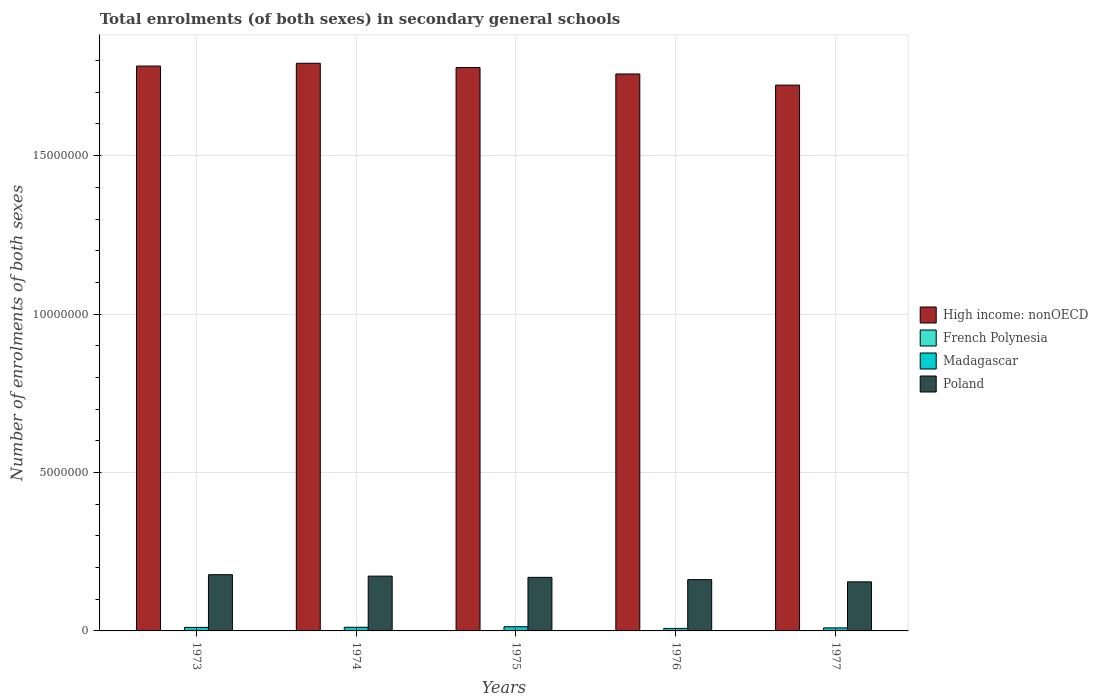How many different coloured bars are there?
Your answer should be very brief. 4. How many bars are there on the 3rd tick from the left?
Keep it short and to the point. 4. How many bars are there on the 5th tick from the right?
Offer a terse response. 4. What is the label of the 3rd group of bars from the left?
Offer a terse response. 1975. What is the number of enrolments in secondary schools in French Polynesia in 1974?
Your response must be concise. 6597. Across all years, what is the maximum number of enrolments in secondary schools in High income: nonOECD?
Give a very brief answer. 1.79e+07. Across all years, what is the minimum number of enrolments in secondary schools in French Polynesia?
Keep it short and to the point. 6239. In which year was the number of enrolments in secondary schools in French Polynesia maximum?
Offer a terse response. 1977. In which year was the number of enrolments in secondary schools in French Polynesia minimum?
Provide a succinct answer. 1973. What is the total number of enrolments in secondary schools in Poland in the graph?
Provide a succinct answer. 8.36e+06. What is the difference between the number of enrolments in secondary schools in Poland in 1974 and that in 1977?
Offer a terse response. 1.81e+05. What is the difference between the number of enrolments in secondary schools in High income: nonOECD in 1973 and the number of enrolments in secondary schools in French Polynesia in 1974?
Keep it short and to the point. 1.78e+07. What is the average number of enrolments in secondary schools in Poland per year?
Make the answer very short. 1.67e+06. In the year 1976, what is the difference between the number of enrolments in secondary schools in Poland and number of enrolments in secondary schools in Madagascar?
Your answer should be very brief. 1.54e+06. What is the ratio of the number of enrolments in secondary schools in French Polynesia in 1976 to that in 1977?
Your answer should be very brief. 0.94. Is the difference between the number of enrolments in secondary schools in Poland in 1974 and 1975 greater than the difference between the number of enrolments in secondary schools in Madagascar in 1974 and 1975?
Provide a succinct answer. Yes. What is the difference between the highest and the second highest number of enrolments in secondary schools in Madagascar?
Your answer should be very brief. 1.74e+04. What is the difference between the highest and the lowest number of enrolments in secondary schools in Madagascar?
Keep it short and to the point. 5.29e+04. In how many years, is the number of enrolments in secondary schools in High income: nonOECD greater than the average number of enrolments in secondary schools in High income: nonOECD taken over all years?
Your answer should be very brief. 3. What does the 4th bar from the left in 1975 represents?
Provide a succinct answer. Poland. What does the 3rd bar from the right in 1976 represents?
Provide a short and direct response. French Polynesia. Is it the case that in every year, the sum of the number of enrolments in secondary schools in Madagascar and number of enrolments in secondary schools in Poland is greater than the number of enrolments in secondary schools in High income: nonOECD?
Make the answer very short. No. Are all the bars in the graph horizontal?
Keep it short and to the point. No. How many years are there in the graph?
Your response must be concise. 5. What is the title of the graph?
Keep it short and to the point. Total enrolments (of both sexes) in secondary general schools. What is the label or title of the Y-axis?
Provide a succinct answer. Number of enrolments of both sexes. What is the Number of enrolments of both sexes of High income: nonOECD in 1973?
Make the answer very short. 1.78e+07. What is the Number of enrolments of both sexes of French Polynesia in 1973?
Keep it short and to the point. 6239. What is the Number of enrolments of both sexes in Madagascar in 1973?
Offer a terse response. 1.11e+05. What is the Number of enrolments of both sexes of Poland in 1973?
Give a very brief answer. 1.77e+06. What is the Number of enrolments of both sexes in High income: nonOECD in 1974?
Provide a succinct answer. 1.79e+07. What is the Number of enrolments of both sexes of French Polynesia in 1974?
Give a very brief answer. 6597. What is the Number of enrolments of both sexes in Madagascar in 1974?
Give a very brief answer. 1.14e+05. What is the Number of enrolments of both sexes of Poland in 1974?
Your response must be concise. 1.73e+06. What is the Number of enrolments of both sexes in High income: nonOECD in 1975?
Make the answer very short. 1.78e+07. What is the Number of enrolments of both sexes of French Polynesia in 1975?
Give a very brief answer. 7046. What is the Number of enrolments of both sexes in Madagascar in 1975?
Keep it short and to the point. 1.32e+05. What is the Number of enrolments of both sexes in Poland in 1975?
Keep it short and to the point. 1.69e+06. What is the Number of enrolments of both sexes in High income: nonOECD in 1976?
Provide a short and direct response. 1.76e+07. What is the Number of enrolments of both sexes in French Polynesia in 1976?
Provide a succinct answer. 7280. What is the Number of enrolments of both sexes of Madagascar in 1976?
Make the answer very short. 7.90e+04. What is the Number of enrolments of both sexes in Poland in 1976?
Offer a very short reply. 1.62e+06. What is the Number of enrolments of both sexes of High income: nonOECD in 1977?
Offer a very short reply. 1.72e+07. What is the Number of enrolments of both sexes in French Polynesia in 1977?
Keep it short and to the point. 7727. What is the Number of enrolments of both sexes in Madagascar in 1977?
Your answer should be very brief. 9.56e+04. What is the Number of enrolments of both sexes of Poland in 1977?
Ensure brevity in your answer.  1.55e+06. Across all years, what is the maximum Number of enrolments of both sexes in High income: nonOECD?
Provide a succinct answer. 1.79e+07. Across all years, what is the maximum Number of enrolments of both sexes in French Polynesia?
Your answer should be very brief. 7727. Across all years, what is the maximum Number of enrolments of both sexes in Madagascar?
Ensure brevity in your answer.  1.32e+05. Across all years, what is the maximum Number of enrolments of both sexes of Poland?
Provide a short and direct response. 1.77e+06. Across all years, what is the minimum Number of enrolments of both sexes in High income: nonOECD?
Make the answer very short. 1.72e+07. Across all years, what is the minimum Number of enrolments of both sexes of French Polynesia?
Your answer should be very brief. 6239. Across all years, what is the minimum Number of enrolments of both sexes of Madagascar?
Your answer should be compact. 7.90e+04. Across all years, what is the minimum Number of enrolments of both sexes in Poland?
Your response must be concise. 1.55e+06. What is the total Number of enrolments of both sexes of High income: nonOECD in the graph?
Keep it short and to the point. 8.83e+07. What is the total Number of enrolments of both sexes of French Polynesia in the graph?
Keep it short and to the point. 3.49e+04. What is the total Number of enrolments of both sexes in Madagascar in the graph?
Your answer should be very brief. 5.32e+05. What is the total Number of enrolments of both sexes in Poland in the graph?
Offer a very short reply. 8.36e+06. What is the difference between the Number of enrolments of both sexes of High income: nonOECD in 1973 and that in 1974?
Make the answer very short. -8.85e+04. What is the difference between the Number of enrolments of both sexes of French Polynesia in 1973 and that in 1974?
Offer a terse response. -358. What is the difference between the Number of enrolments of both sexes in Madagascar in 1973 and that in 1974?
Your response must be concise. -3052. What is the difference between the Number of enrolments of both sexes of Poland in 1973 and that in 1974?
Ensure brevity in your answer.  4.52e+04. What is the difference between the Number of enrolments of both sexes of High income: nonOECD in 1973 and that in 1975?
Your response must be concise. 4.70e+04. What is the difference between the Number of enrolments of both sexes in French Polynesia in 1973 and that in 1975?
Provide a short and direct response. -807. What is the difference between the Number of enrolments of both sexes of Madagascar in 1973 and that in 1975?
Your answer should be compact. -2.04e+04. What is the difference between the Number of enrolments of both sexes of Poland in 1973 and that in 1975?
Provide a succinct answer. 8.43e+04. What is the difference between the Number of enrolments of both sexes of High income: nonOECD in 1973 and that in 1976?
Make the answer very short. 2.50e+05. What is the difference between the Number of enrolments of both sexes of French Polynesia in 1973 and that in 1976?
Give a very brief answer. -1041. What is the difference between the Number of enrolments of both sexes of Madagascar in 1973 and that in 1976?
Ensure brevity in your answer.  3.25e+04. What is the difference between the Number of enrolments of both sexes in Poland in 1973 and that in 1976?
Your response must be concise. 1.56e+05. What is the difference between the Number of enrolments of both sexes in High income: nonOECD in 1973 and that in 1977?
Make the answer very short. 6.01e+05. What is the difference between the Number of enrolments of both sexes of French Polynesia in 1973 and that in 1977?
Provide a succinct answer. -1488. What is the difference between the Number of enrolments of both sexes of Madagascar in 1973 and that in 1977?
Your answer should be compact. 1.58e+04. What is the difference between the Number of enrolments of both sexes in Poland in 1973 and that in 1977?
Provide a succinct answer. 2.26e+05. What is the difference between the Number of enrolments of both sexes in High income: nonOECD in 1974 and that in 1975?
Keep it short and to the point. 1.36e+05. What is the difference between the Number of enrolments of both sexes in French Polynesia in 1974 and that in 1975?
Your response must be concise. -449. What is the difference between the Number of enrolments of both sexes in Madagascar in 1974 and that in 1975?
Your response must be concise. -1.74e+04. What is the difference between the Number of enrolments of both sexes in Poland in 1974 and that in 1975?
Your answer should be compact. 3.90e+04. What is the difference between the Number of enrolments of both sexes of High income: nonOECD in 1974 and that in 1976?
Keep it short and to the point. 3.38e+05. What is the difference between the Number of enrolments of both sexes in French Polynesia in 1974 and that in 1976?
Provide a short and direct response. -683. What is the difference between the Number of enrolments of both sexes of Madagascar in 1974 and that in 1976?
Keep it short and to the point. 3.55e+04. What is the difference between the Number of enrolments of both sexes in Poland in 1974 and that in 1976?
Keep it short and to the point. 1.11e+05. What is the difference between the Number of enrolments of both sexes of High income: nonOECD in 1974 and that in 1977?
Provide a short and direct response. 6.89e+05. What is the difference between the Number of enrolments of both sexes in French Polynesia in 1974 and that in 1977?
Your answer should be very brief. -1130. What is the difference between the Number of enrolments of both sexes in Madagascar in 1974 and that in 1977?
Your response must be concise. 1.89e+04. What is the difference between the Number of enrolments of both sexes of Poland in 1974 and that in 1977?
Give a very brief answer. 1.81e+05. What is the difference between the Number of enrolments of both sexes in High income: nonOECD in 1975 and that in 1976?
Provide a short and direct response. 2.03e+05. What is the difference between the Number of enrolments of both sexes in French Polynesia in 1975 and that in 1976?
Give a very brief answer. -234. What is the difference between the Number of enrolments of both sexes in Madagascar in 1975 and that in 1976?
Offer a very short reply. 5.29e+04. What is the difference between the Number of enrolments of both sexes in Poland in 1975 and that in 1976?
Offer a terse response. 7.18e+04. What is the difference between the Number of enrolments of both sexes of High income: nonOECD in 1975 and that in 1977?
Keep it short and to the point. 5.54e+05. What is the difference between the Number of enrolments of both sexes in French Polynesia in 1975 and that in 1977?
Provide a short and direct response. -681. What is the difference between the Number of enrolments of both sexes in Madagascar in 1975 and that in 1977?
Offer a very short reply. 3.62e+04. What is the difference between the Number of enrolments of both sexes of Poland in 1975 and that in 1977?
Provide a short and direct response. 1.42e+05. What is the difference between the Number of enrolments of both sexes of High income: nonOECD in 1976 and that in 1977?
Offer a terse response. 3.51e+05. What is the difference between the Number of enrolments of both sexes in French Polynesia in 1976 and that in 1977?
Your response must be concise. -447. What is the difference between the Number of enrolments of both sexes of Madagascar in 1976 and that in 1977?
Keep it short and to the point. -1.66e+04. What is the difference between the Number of enrolments of both sexes of Poland in 1976 and that in 1977?
Offer a terse response. 7.04e+04. What is the difference between the Number of enrolments of both sexes in High income: nonOECD in 1973 and the Number of enrolments of both sexes in French Polynesia in 1974?
Keep it short and to the point. 1.78e+07. What is the difference between the Number of enrolments of both sexes in High income: nonOECD in 1973 and the Number of enrolments of both sexes in Madagascar in 1974?
Provide a succinct answer. 1.77e+07. What is the difference between the Number of enrolments of both sexes in High income: nonOECD in 1973 and the Number of enrolments of both sexes in Poland in 1974?
Your answer should be compact. 1.61e+07. What is the difference between the Number of enrolments of both sexes of French Polynesia in 1973 and the Number of enrolments of both sexes of Madagascar in 1974?
Offer a terse response. -1.08e+05. What is the difference between the Number of enrolments of both sexes in French Polynesia in 1973 and the Number of enrolments of both sexes in Poland in 1974?
Provide a short and direct response. -1.72e+06. What is the difference between the Number of enrolments of both sexes in Madagascar in 1973 and the Number of enrolments of both sexes in Poland in 1974?
Your answer should be compact. -1.62e+06. What is the difference between the Number of enrolments of both sexes of High income: nonOECD in 1973 and the Number of enrolments of both sexes of French Polynesia in 1975?
Offer a very short reply. 1.78e+07. What is the difference between the Number of enrolments of both sexes of High income: nonOECD in 1973 and the Number of enrolments of both sexes of Madagascar in 1975?
Ensure brevity in your answer.  1.77e+07. What is the difference between the Number of enrolments of both sexes of High income: nonOECD in 1973 and the Number of enrolments of both sexes of Poland in 1975?
Offer a very short reply. 1.61e+07. What is the difference between the Number of enrolments of both sexes in French Polynesia in 1973 and the Number of enrolments of both sexes in Madagascar in 1975?
Your answer should be compact. -1.26e+05. What is the difference between the Number of enrolments of both sexes of French Polynesia in 1973 and the Number of enrolments of both sexes of Poland in 1975?
Make the answer very short. -1.68e+06. What is the difference between the Number of enrolments of both sexes of Madagascar in 1973 and the Number of enrolments of both sexes of Poland in 1975?
Ensure brevity in your answer.  -1.58e+06. What is the difference between the Number of enrolments of both sexes of High income: nonOECD in 1973 and the Number of enrolments of both sexes of French Polynesia in 1976?
Your answer should be very brief. 1.78e+07. What is the difference between the Number of enrolments of both sexes in High income: nonOECD in 1973 and the Number of enrolments of both sexes in Madagascar in 1976?
Provide a short and direct response. 1.77e+07. What is the difference between the Number of enrolments of both sexes in High income: nonOECD in 1973 and the Number of enrolments of both sexes in Poland in 1976?
Your answer should be compact. 1.62e+07. What is the difference between the Number of enrolments of both sexes of French Polynesia in 1973 and the Number of enrolments of both sexes of Madagascar in 1976?
Your answer should be very brief. -7.27e+04. What is the difference between the Number of enrolments of both sexes in French Polynesia in 1973 and the Number of enrolments of both sexes in Poland in 1976?
Ensure brevity in your answer.  -1.61e+06. What is the difference between the Number of enrolments of both sexes of Madagascar in 1973 and the Number of enrolments of both sexes of Poland in 1976?
Provide a short and direct response. -1.51e+06. What is the difference between the Number of enrolments of both sexes in High income: nonOECD in 1973 and the Number of enrolments of both sexes in French Polynesia in 1977?
Your answer should be very brief. 1.78e+07. What is the difference between the Number of enrolments of both sexes in High income: nonOECD in 1973 and the Number of enrolments of both sexes in Madagascar in 1977?
Give a very brief answer. 1.77e+07. What is the difference between the Number of enrolments of both sexes of High income: nonOECD in 1973 and the Number of enrolments of both sexes of Poland in 1977?
Offer a very short reply. 1.63e+07. What is the difference between the Number of enrolments of both sexes in French Polynesia in 1973 and the Number of enrolments of both sexes in Madagascar in 1977?
Keep it short and to the point. -8.94e+04. What is the difference between the Number of enrolments of both sexes in French Polynesia in 1973 and the Number of enrolments of both sexes in Poland in 1977?
Ensure brevity in your answer.  -1.54e+06. What is the difference between the Number of enrolments of both sexes in Madagascar in 1973 and the Number of enrolments of both sexes in Poland in 1977?
Offer a terse response. -1.44e+06. What is the difference between the Number of enrolments of both sexes in High income: nonOECD in 1974 and the Number of enrolments of both sexes in French Polynesia in 1975?
Offer a very short reply. 1.79e+07. What is the difference between the Number of enrolments of both sexes in High income: nonOECD in 1974 and the Number of enrolments of both sexes in Madagascar in 1975?
Offer a terse response. 1.78e+07. What is the difference between the Number of enrolments of both sexes of High income: nonOECD in 1974 and the Number of enrolments of both sexes of Poland in 1975?
Your response must be concise. 1.62e+07. What is the difference between the Number of enrolments of both sexes in French Polynesia in 1974 and the Number of enrolments of both sexes in Madagascar in 1975?
Ensure brevity in your answer.  -1.25e+05. What is the difference between the Number of enrolments of both sexes of French Polynesia in 1974 and the Number of enrolments of both sexes of Poland in 1975?
Your answer should be compact. -1.68e+06. What is the difference between the Number of enrolments of both sexes of Madagascar in 1974 and the Number of enrolments of both sexes of Poland in 1975?
Keep it short and to the point. -1.58e+06. What is the difference between the Number of enrolments of both sexes in High income: nonOECD in 1974 and the Number of enrolments of both sexes in French Polynesia in 1976?
Keep it short and to the point. 1.79e+07. What is the difference between the Number of enrolments of both sexes of High income: nonOECD in 1974 and the Number of enrolments of both sexes of Madagascar in 1976?
Offer a terse response. 1.78e+07. What is the difference between the Number of enrolments of both sexes in High income: nonOECD in 1974 and the Number of enrolments of both sexes in Poland in 1976?
Your answer should be very brief. 1.63e+07. What is the difference between the Number of enrolments of both sexes of French Polynesia in 1974 and the Number of enrolments of both sexes of Madagascar in 1976?
Offer a terse response. -7.24e+04. What is the difference between the Number of enrolments of both sexes in French Polynesia in 1974 and the Number of enrolments of both sexes in Poland in 1976?
Your response must be concise. -1.61e+06. What is the difference between the Number of enrolments of both sexes in Madagascar in 1974 and the Number of enrolments of both sexes in Poland in 1976?
Make the answer very short. -1.50e+06. What is the difference between the Number of enrolments of both sexes in High income: nonOECD in 1974 and the Number of enrolments of both sexes in French Polynesia in 1977?
Your answer should be compact. 1.79e+07. What is the difference between the Number of enrolments of both sexes of High income: nonOECD in 1974 and the Number of enrolments of both sexes of Madagascar in 1977?
Offer a terse response. 1.78e+07. What is the difference between the Number of enrolments of both sexes of High income: nonOECD in 1974 and the Number of enrolments of both sexes of Poland in 1977?
Ensure brevity in your answer.  1.64e+07. What is the difference between the Number of enrolments of both sexes in French Polynesia in 1974 and the Number of enrolments of both sexes in Madagascar in 1977?
Offer a very short reply. -8.90e+04. What is the difference between the Number of enrolments of both sexes in French Polynesia in 1974 and the Number of enrolments of both sexes in Poland in 1977?
Ensure brevity in your answer.  -1.54e+06. What is the difference between the Number of enrolments of both sexes in Madagascar in 1974 and the Number of enrolments of both sexes in Poland in 1977?
Offer a very short reply. -1.43e+06. What is the difference between the Number of enrolments of both sexes in High income: nonOECD in 1975 and the Number of enrolments of both sexes in French Polynesia in 1976?
Ensure brevity in your answer.  1.78e+07. What is the difference between the Number of enrolments of both sexes in High income: nonOECD in 1975 and the Number of enrolments of both sexes in Madagascar in 1976?
Your answer should be very brief. 1.77e+07. What is the difference between the Number of enrolments of both sexes of High income: nonOECD in 1975 and the Number of enrolments of both sexes of Poland in 1976?
Offer a terse response. 1.62e+07. What is the difference between the Number of enrolments of both sexes in French Polynesia in 1975 and the Number of enrolments of both sexes in Madagascar in 1976?
Provide a short and direct response. -7.19e+04. What is the difference between the Number of enrolments of both sexes of French Polynesia in 1975 and the Number of enrolments of both sexes of Poland in 1976?
Provide a succinct answer. -1.61e+06. What is the difference between the Number of enrolments of both sexes of Madagascar in 1975 and the Number of enrolments of both sexes of Poland in 1976?
Provide a succinct answer. -1.49e+06. What is the difference between the Number of enrolments of both sexes in High income: nonOECD in 1975 and the Number of enrolments of both sexes in French Polynesia in 1977?
Provide a short and direct response. 1.78e+07. What is the difference between the Number of enrolments of both sexes in High income: nonOECD in 1975 and the Number of enrolments of both sexes in Madagascar in 1977?
Offer a very short reply. 1.77e+07. What is the difference between the Number of enrolments of both sexes in High income: nonOECD in 1975 and the Number of enrolments of both sexes in Poland in 1977?
Offer a very short reply. 1.62e+07. What is the difference between the Number of enrolments of both sexes in French Polynesia in 1975 and the Number of enrolments of both sexes in Madagascar in 1977?
Your response must be concise. -8.85e+04. What is the difference between the Number of enrolments of both sexes of French Polynesia in 1975 and the Number of enrolments of both sexes of Poland in 1977?
Provide a succinct answer. -1.54e+06. What is the difference between the Number of enrolments of both sexes in Madagascar in 1975 and the Number of enrolments of both sexes in Poland in 1977?
Offer a very short reply. -1.42e+06. What is the difference between the Number of enrolments of both sexes of High income: nonOECD in 1976 and the Number of enrolments of both sexes of French Polynesia in 1977?
Your answer should be compact. 1.76e+07. What is the difference between the Number of enrolments of both sexes of High income: nonOECD in 1976 and the Number of enrolments of both sexes of Madagascar in 1977?
Your answer should be compact. 1.75e+07. What is the difference between the Number of enrolments of both sexes in High income: nonOECD in 1976 and the Number of enrolments of both sexes in Poland in 1977?
Give a very brief answer. 1.60e+07. What is the difference between the Number of enrolments of both sexes of French Polynesia in 1976 and the Number of enrolments of both sexes of Madagascar in 1977?
Make the answer very short. -8.83e+04. What is the difference between the Number of enrolments of both sexes of French Polynesia in 1976 and the Number of enrolments of both sexes of Poland in 1977?
Make the answer very short. -1.54e+06. What is the difference between the Number of enrolments of both sexes of Madagascar in 1976 and the Number of enrolments of both sexes of Poland in 1977?
Keep it short and to the point. -1.47e+06. What is the average Number of enrolments of both sexes in High income: nonOECD per year?
Provide a succinct answer. 1.77e+07. What is the average Number of enrolments of both sexes in French Polynesia per year?
Your answer should be compact. 6977.8. What is the average Number of enrolments of both sexes of Madagascar per year?
Keep it short and to the point. 1.06e+05. What is the average Number of enrolments of both sexes in Poland per year?
Keep it short and to the point. 1.67e+06. In the year 1973, what is the difference between the Number of enrolments of both sexes in High income: nonOECD and Number of enrolments of both sexes in French Polynesia?
Provide a succinct answer. 1.78e+07. In the year 1973, what is the difference between the Number of enrolments of both sexes of High income: nonOECD and Number of enrolments of both sexes of Madagascar?
Offer a very short reply. 1.77e+07. In the year 1973, what is the difference between the Number of enrolments of both sexes in High income: nonOECD and Number of enrolments of both sexes in Poland?
Give a very brief answer. 1.61e+07. In the year 1973, what is the difference between the Number of enrolments of both sexes of French Polynesia and Number of enrolments of both sexes of Madagascar?
Your answer should be compact. -1.05e+05. In the year 1973, what is the difference between the Number of enrolments of both sexes in French Polynesia and Number of enrolments of both sexes in Poland?
Give a very brief answer. -1.77e+06. In the year 1973, what is the difference between the Number of enrolments of both sexes in Madagascar and Number of enrolments of both sexes in Poland?
Make the answer very short. -1.66e+06. In the year 1974, what is the difference between the Number of enrolments of both sexes in High income: nonOECD and Number of enrolments of both sexes in French Polynesia?
Offer a very short reply. 1.79e+07. In the year 1974, what is the difference between the Number of enrolments of both sexes of High income: nonOECD and Number of enrolments of both sexes of Madagascar?
Offer a terse response. 1.78e+07. In the year 1974, what is the difference between the Number of enrolments of both sexes of High income: nonOECD and Number of enrolments of both sexes of Poland?
Provide a succinct answer. 1.62e+07. In the year 1974, what is the difference between the Number of enrolments of both sexes of French Polynesia and Number of enrolments of both sexes of Madagascar?
Provide a succinct answer. -1.08e+05. In the year 1974, what is the difference between the Number of enrolments of both sexes in French Polynesia and Number of enrolments of both sexes in Poland?
Offer a terse response. -1.72e+06. In the year 1974, what is the difference between the Number of enrolments of both sexes in Madagascar and Number of enrolments of both sexes in Poland?
Ensure brevity in your answer.  -1.62e+06. In the year 1975, what is the difference between the Number of enrolments of both sexes of High income: nonOECD and Number of enrolments of both sexes of French Polynesia?
Keep it short and to the point. 1.78e+07. In the year 1975, what is the difference between the Number of enrolments of both sexes in High income: nonOECD and Number of enrolments of both sexes in Madagascar?
Offer a terse response. 1.76e+07. In the year 1975, what is the difference between the Number of enrolments of both sexes of High income: nonOECD and Number of enrolments of both sexes of Poland?
Your answer should be very brief. 1.61e+07. In the year 1975, what is the difference between the Number of enrolments of both sexes of French Polynesia and Number of enrolments of both sexes of Madagascar?
Provide a short and direct response. -1.25e+05. In the year 1975, what is the difference between the Number of enrolments of both sexes in French Polynesia and Number of enrolments of both sexes in Poland?
Your answer should be very brief. -1.68e+06. In the year 1975, what is the difference between the Number of enrolments of both sexes of Madagascar and Number of enrolments of both sexes of Poland?
Your response must be concise. -1.56e+06. In the year 1976, what is the difference between the Number of enrolments of both sexes in High income: nonOECD and Number of enrolments of both sexes in French Polynesia?
Provide a short and direct response. 1.76e+07. In the year 1976, what is the difference between the Number of enrolments of both sexes in High income: nonOECD and Number of enrolments of both sexes in Madagascar?
Keep it short and to the point. 1.75e+07. In the year 1976, what is the difference between the Number of enrolments of both sexes in High income: nonOECD and Number of enrolments of both sexes in Poland?
Provide a short and direct response. 1.60e+07. In the year 1976, what is the difference between the Number of enrolments of both sexes of French Polynesia and Number of enrolments of both sexes of Madagascar?
Offer a terse response. -7.17e+04. In the year 1976, what is the difference between the Number of enrolments of both sexes in French Polynesia and Number of enrolments of both sexes in Poland?
Make the answer very short. -1.61e+06. In the year 1976, what is the difference between the Number of enrolments of both sexes of Madagascar and Number of enrolments of both sexes of Poland?
Your answer should be very brief. -1.54e+06. In the year 1977, what is the difference between the Number of enrolments of both sexes of High income: nonOECD and Number of enrolments of both sexes of French Polynesia?
Offer a very short reply. 1.72e+07. In the year 1977, what is the difference between the Number of enrolments of both sexes in High income: nonOECD and Number of enrolments of both sexes in Madagascar?
Make the answer very short. 1.71e+07. In the year 1977, what is the difference between the Number of enrolments of both sexes of High income: nonOECD and Number of enrolments of both sexes of Poland?
Offer a very short reply. 1.57e+07. In the year 1977, what is the difference between the Number of enrolments of both sexes of French Polynesia and Number of enrolments of both sexes of Madagascar?
Provide a succinct answer. -8.79e+04. In the year 1977, what is the difference between the Number of enrolments of both sexes of French Polynesia and Number of enrolments of both sexes of Poland?
Offer a terse response. -1.54e+06. In the year 1977, what is the difference between the Number of enrolments of both sexes of Madagascar and Number of enrolments of both sexes of Poland?
Your answer should be very brief. -1.45e+06. What is the ratio of the Number of enrolments of both sexes of French Polynesia in 1973 to that in 1974?
Offer a terse response. 0.95. What is the ratio of the Number of enrolments of both sexes of Madagascar in 1973 to that in 1974?
Give a very brief answer. 0.97. What is the ratio of the Number of enrolments of both sexes in Poland in 1973 to that in 1974?
Give a very brief answer. 1.03. What is the ratio of the Number of enrolments of both sexes in High income: nonOECD in 1973 to that in 1975?
Your answer should be very brief. 1. What is the ratio of the Number of enrolments of both sexes in French Polynesia in 1973 to that in 1975?
Ensure brevity in your answer.  0.89. What is the ratio of the Number of enrolments of both sexes of Madagascar in 1973 to that in 1975?
Offer a very short reply. 0.85. What is the ratio of the Number of enrolments of both sexes in Poland in 1973 to that in 1975?
Give a very brief answer. 1.05. What is the ratio of the Number of enrolments of both sexes in High income: nonOECD in 1973 to that in 1976?
Offer a terse response. 1.01. What is the ratio of the Number of enrolments of both sexes of French Polynesia in 1973 to that in 1976?
Offer a very short reply. 0.86. What is the ratio of the Number of enrolments of both sexes of Madagascar in 1973 to that in 1976?
Provide a short and direct response. 1.41. What is the ratio of the Number of enrolments of both sexes of Poland in 1973 to that in 1976?
Keep it short and to the point. 1.1. What is the ratio of the Number of enrolments of both sexes of High income: nonOECD in 1973 to that in 1977?
Provide a short and direct response. 1.03. What is the ratio of the Number of enrolments of both sexes in French Polynesia in 1973 to that in 1977?
Your answer should be very brief. 0.81. What is the ratio of the Number of enrolments of both sexes of Madagascar in 1973 to that in 1977?
Give a very brief answer. 1.17. What is the ratio of the Number of enrolments of both sexes in Poland in 1973 to that in 1977?
Your answer should be very brief. 1.15. What is the ratio of the Number of enrolments of both sexes in High income: nonOECD in 1974 to that in 1975?
Provide a short and direct response. 1.01. What is the ratio of the Number of enrolments of both sexes of French Polynesia in 1974 to that in 1975?
Your answer should be very brief. 0.94. What is the ratio of the Number of enrolments of both sexes in Madagascar in 1974 to that in 1975?
Ensure brevity in your answer.  0.87. What is the ratio of the Number of enrolments of both sexes in Poland in 1974 to that in 1975?
Make the answer very short. 1.02. What is the ratio of the Number of enrolments of both sexes of High income: nonOECD in 1974 to that in 1976?
Offer a terse response. 1.02. What is the ratio of the Number of enrolments of both sexes of French Polynesia in 1974 to that in 1976?
Ensure brevity in your answer.  0.91. What is the ratio of the Number of enrolments of both sexes of Madagascar in 1974 to that in 1976?
Your answer should be very brief. 1.45. What is the ratio of the Number of enrolments of both sexes of Poland in 1974 to that in 1976?
Provide a succinct answer. 1.07. What is the ratio of the Number of enrolments of both sexes of High income: nonOECD in 1974 to that in 1977?
Provide a succinct answer. 1.04. What is the ratio of the Number of enrolments of both sexes in French Polynesia in 1974 to that in 1977?
Give a very brief answer. 0.85. What is the ratio of the Number of enrolments of both sexes in Madagascar in 1974 to that in 1977?
Offer a very short reply. 1.2. What is the ratio of the Number of enrolments of both sexes of Poland in 1974 to that in 1977?
Provide a short and direct response. 1.12. What is the ratio of the Number of enrolments of both sexes of High income: nonOECD in 1975 to that in 1976?
Your answer should be compact. 1.01. What is the ratio of the Number of enrolments of both sexes in French Polynesia in 1975 to that in 1976?
Keep it short and to the point. 0.97. What is the ratio of the Number of enrolments of both sexes in Madagascar in 1975 to that in 1976?
Ensure brevity in your answer.  1.67. What is the ratio of the Number of enrolments of both sexes in Poland in 1975 to that in 1976?
Provide a short and direct response. 1.04. What is the ratio of the Number of enrolments of both sexes in High income: nonOECD in 1975 to that in 1977?
Provide a succinct answer. 1.03. What is the ratio of the Number of enrolments of both sexes in French Polynesia in 1975 to that in 1977?
Make the answer very short. 0.91. What is the ratio of the Number of enrolments of both sexes of Madagascar in 1975 to that in 1977?
Provide a short and direct response. 1.38. What is the ratio of the Number of enrolments of both sexes of Poland in 1975 to that in 1977?
Your answer should be very brief. 1.09. What is the ratio of the Number of enrolments of both sexes of High income: nonOECD in 1976 to that in 1977?
Your response must be concise. 1.02. What is the ratio of the Number of enrolments of both sexes in French Polynesia in 1976 to that in 1977?
Your answer should be very brief. 0.94. What is the ratio of the Number of enrolments of both sexes of Madagascar in 1976 to that in 1977?
Provide a short and direct response. 0.83. What is the ratio of the Number of enrolments of both sexes of Poland in 1976 to that in 1977?
Your answer should be very brief. 1.05. What is the difference between the highest and the second highest Number of enrolments of both sexes in High income: nonOECD?
Keep it short and to the point. 8.85e+04. What is the difference between the highest and the second highest Number of enrolments of both sexes in French Polynesia?
Offer a terse response. 447. What is the difference between the highest and the second highest Number of enrolments of both sexes in Madagascar?
Provide a short and direct response. 1.74e+04. What is the difference between the highest and the second highest Number of enrolments of both sexes in Poland?
Offer a terse response. 4.52e+04. What is the difference between the highest and the lowest Number of enrolments of both sexes in High income: nonOECD?
Provide a short and direct response. 6.89e+05. What is the difference between the highest and the lowest Number of enrolments of both sexes in French Polynesia?
Your answer should be very brief. 1488. What is the difference between the highest and the lowest Number of enrolments of both sexes in Madagascar?
Give a very brief answer. 5.29e+04. What is the difference between the highest and the lowest Number of enrolments of both sexes of Poland?
Keep it short and to the point. 2.26e+05. 